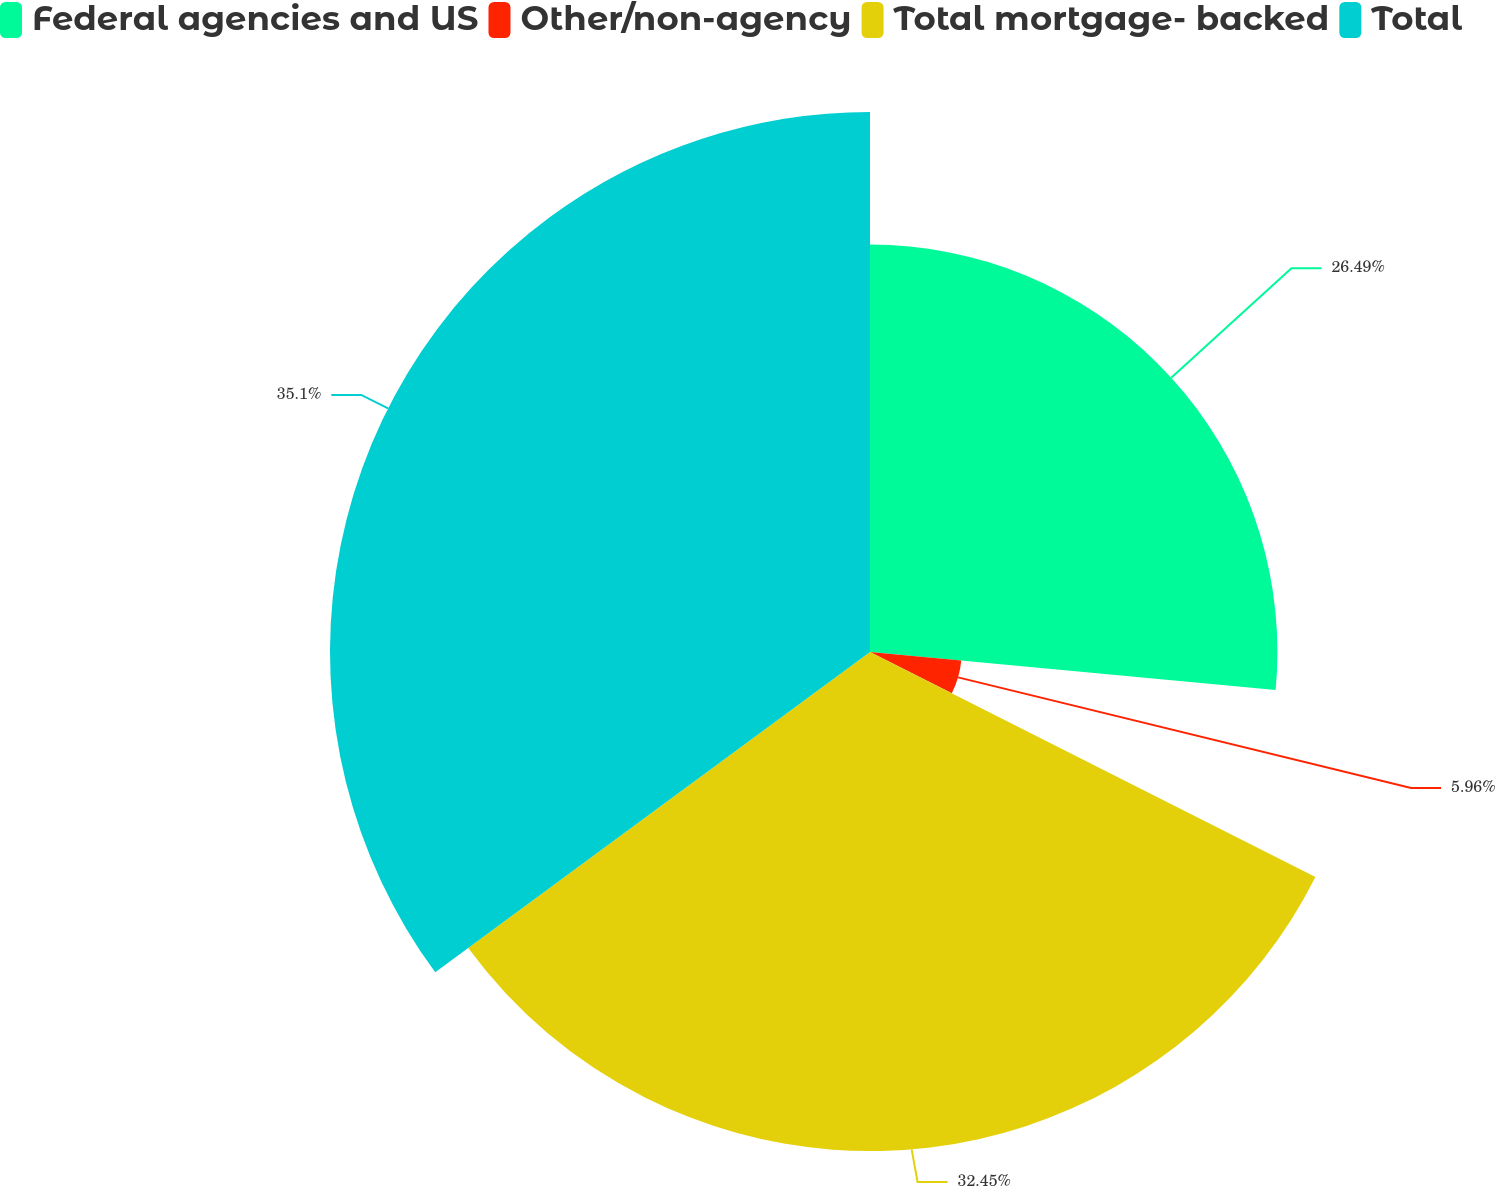Convert chart to OTSL. <chart><loc_0><loc_0><loc_500><loc_500><pie_chart><fcel>Federal agencies and US<fcel>Other/non-agency<fcel>Total mortgage- backed<fcel>Total<nl><fcel>26.49%<fcel>5.96%<fcel>32.45%<fcel>35.11%<nl></chart> 